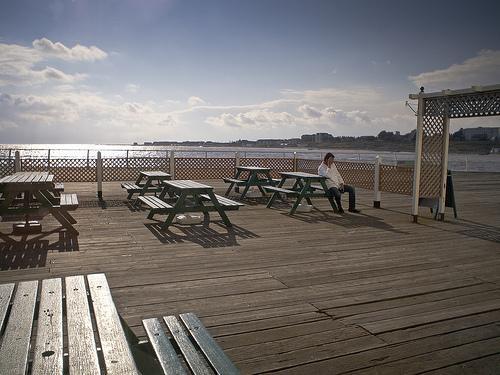How many people are sitting on the chair?
Give a very brief answer. 1. 